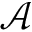Convert formula to latex. <formula><loc_0><loc_0><loc_500><loc_500>\mathcal { A }</formula> 